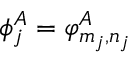<formula> <loc_0><loc_0><loc_500><loc_500>\phi _ { j } ^ { A } = \varphi _ { m _ { j } , n _ { j } } ^ { A }</formula> 